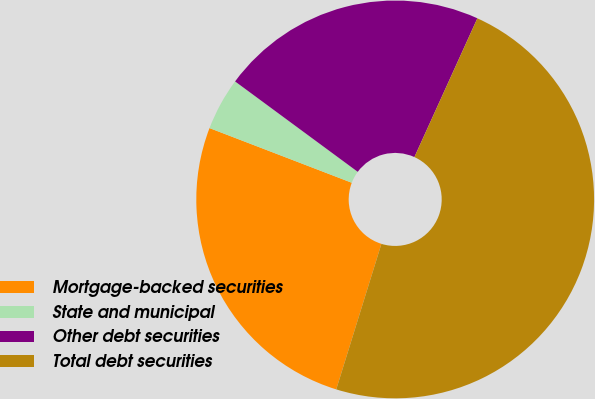Convert chart to OTSL. <chart><loc_0><loc_0><loc_500><loc_500><pie_chart><fcel>Mortgage-backed securities<fcel>State and municipal<fcel>Other debt securities<fcel>Total debt securities<nl><fcel>26.05%<fcel>4.27%<fcel>21.67%<fcel>48.01%<nl></chart> 